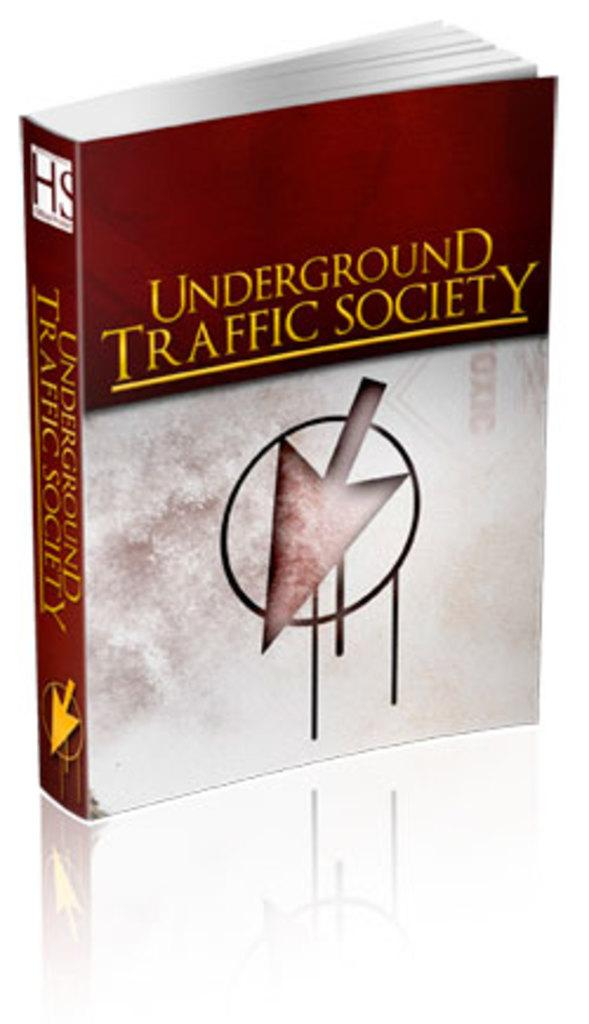<image>
Render a clear and concise summary of the photo. A book titled Underground Traffic Society with a giant arrow on its cover. 